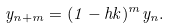Convert formula to latex. <formula><loc_0><loc_0><loc_500><loc_500>y _ { n + m } = ( 1 - h k ) ^ { m } y _ { n } .</formula> 